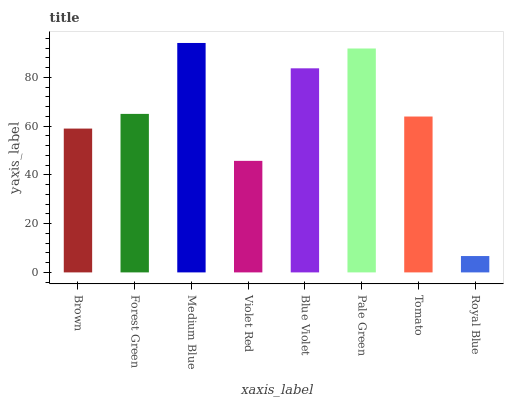Is Royal Blue the minimum?
Answer yes or no. Yes. Is Medium Blue the maximum?
Answer yes or no. Yes. Is Forest Green the minimum?
Answer yes or no. No. Is Forest Green the maximum?
Answer yes or no. No. Is Forest Green greater than Brown?
Answer yes or no. Yes. Is Brown less than Forest Green?
Answer yes or no. Yes. Is Brown greater than Forest Green?
Answer yes or no. No. Is Forest Green less than Brown?
Answer yes or no. No. Is Forest Green the high median?
Answer yes or no. Yes. Is Tomato the low median?
Answer yes or no. Yes. Is Violet Red the high median?
Answer yes or no. No. Is Forest Green the low median?
Answer yes or no. No. 